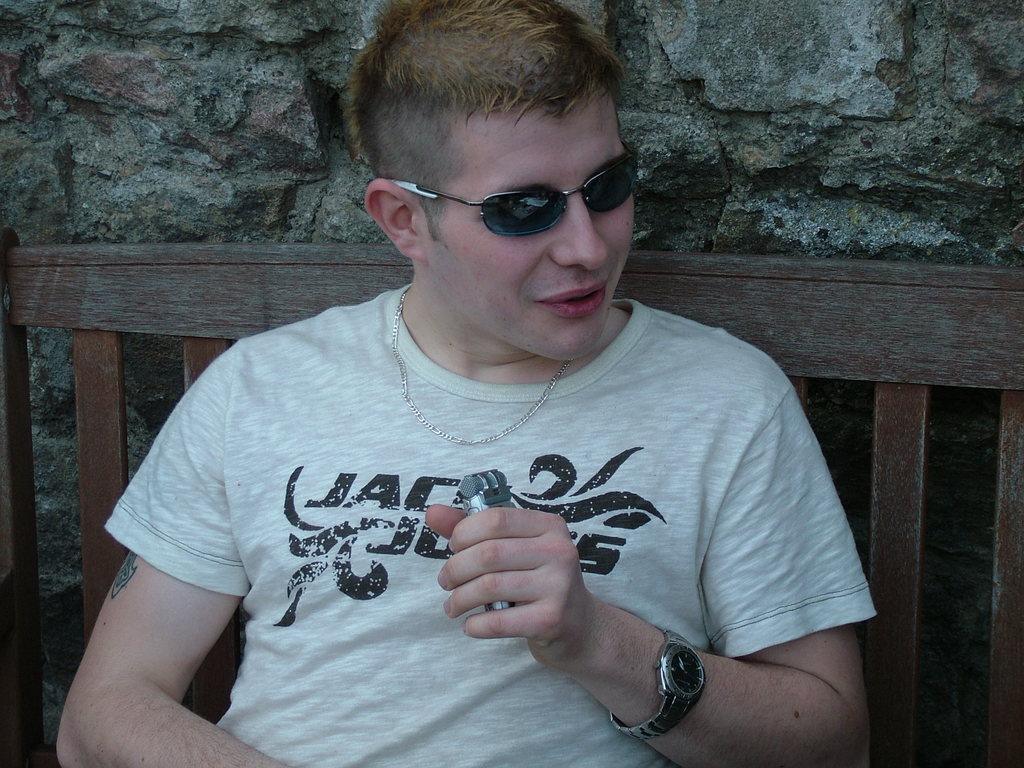Who or what can be seen in the image? There is a person in the image. What is the person doing in the image? The person is holding an object. Where is the person sitting in the image? The person is sitting on a wooden bench. What can be seen in the background of the image? There is a rock wall in the background of the image. What type of bell can be heard ringing in the image? There is no bell present or ringing in the image. How many calculators are visible on the edge of the rock wall in the image? There are no calculators visible in the image, and the rock wall is in the background, not on the edge. 